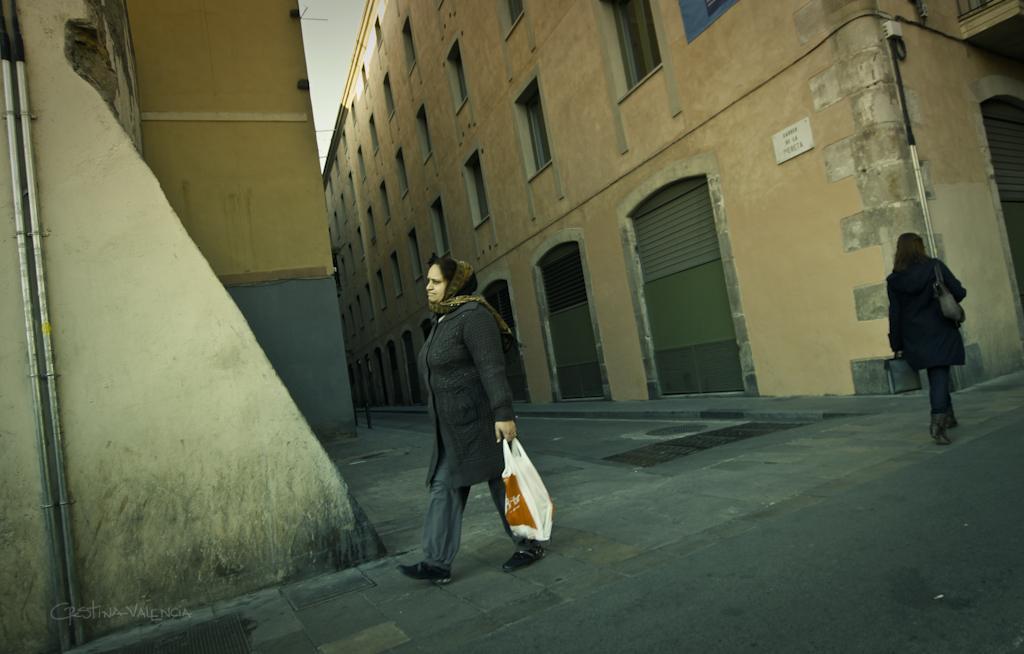Describe this image in one or two sentences. In this picture, there are building on either side of the road which is in the center. In the center, there is a woman wearing black jacket, scarf and holding a plastic bag and she is walking on the footpath. At the bottom, there is another road. Towards the right, there is another woman carrying a bag and holding another bag. 